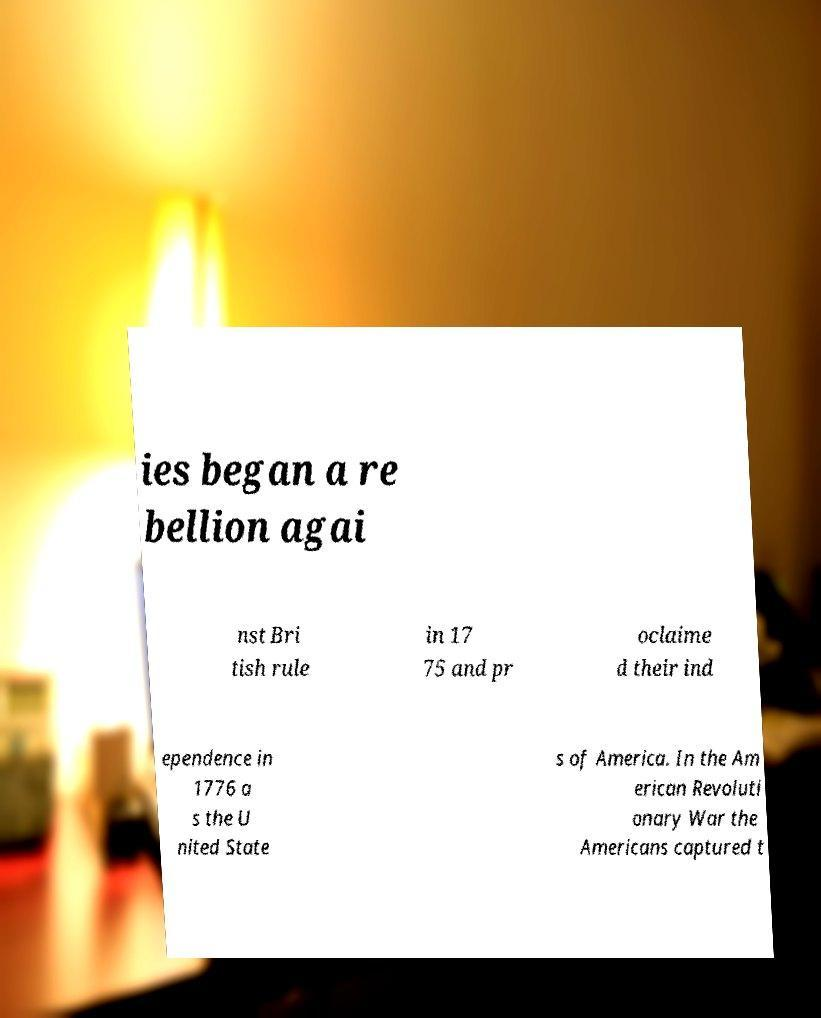Can you accurately transcribe the text from the provided image for me? ies began a re bellion agai nst Bri tish rule in 17 75 and pr oclaime d their ind ependence in 1776 a s the U nited State s of America. In the Am erican Revoluti onary War the Americans captured t 